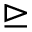<formula> <loc_0><loc_0><loc_500><loc_500>\triangleright e q</formula> 